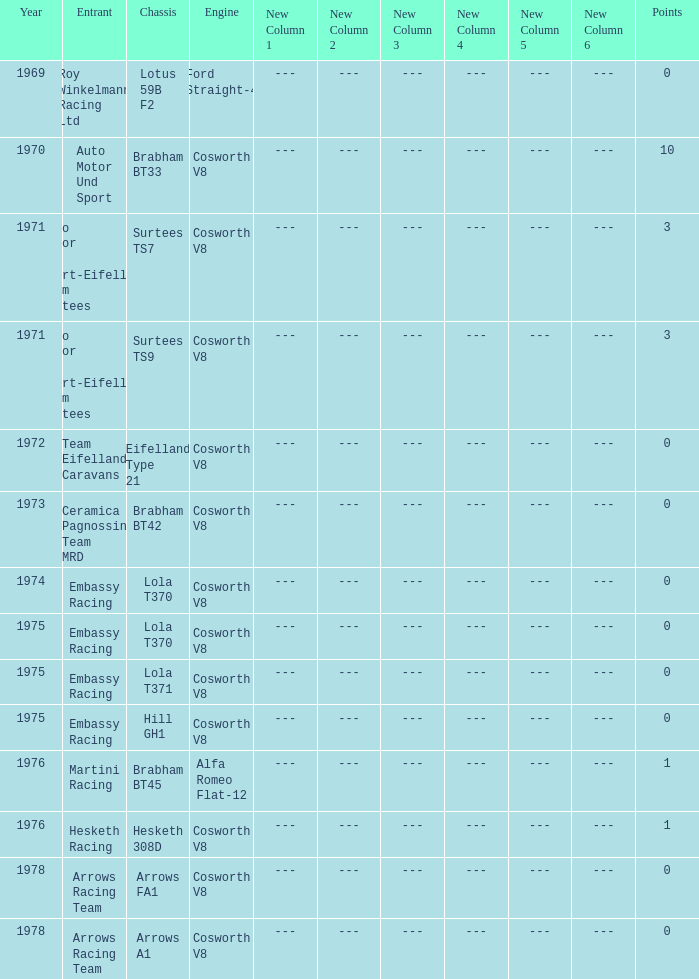In 1970, what entrant had a cosworth v8 engine? Auto Motor Und Sport. 